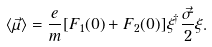<formula> <loc_0><loc_0><loc_500><loc_500>\langle \vec { \mu } \rangle = \frac { e } { m } [ F _ { 1 } ( 0 ) + F _ { 2 } ( 0 ) ] \xi ^ { \dagger } \frac { \vec { \sigma } } { 2 } \xi .</formula> 